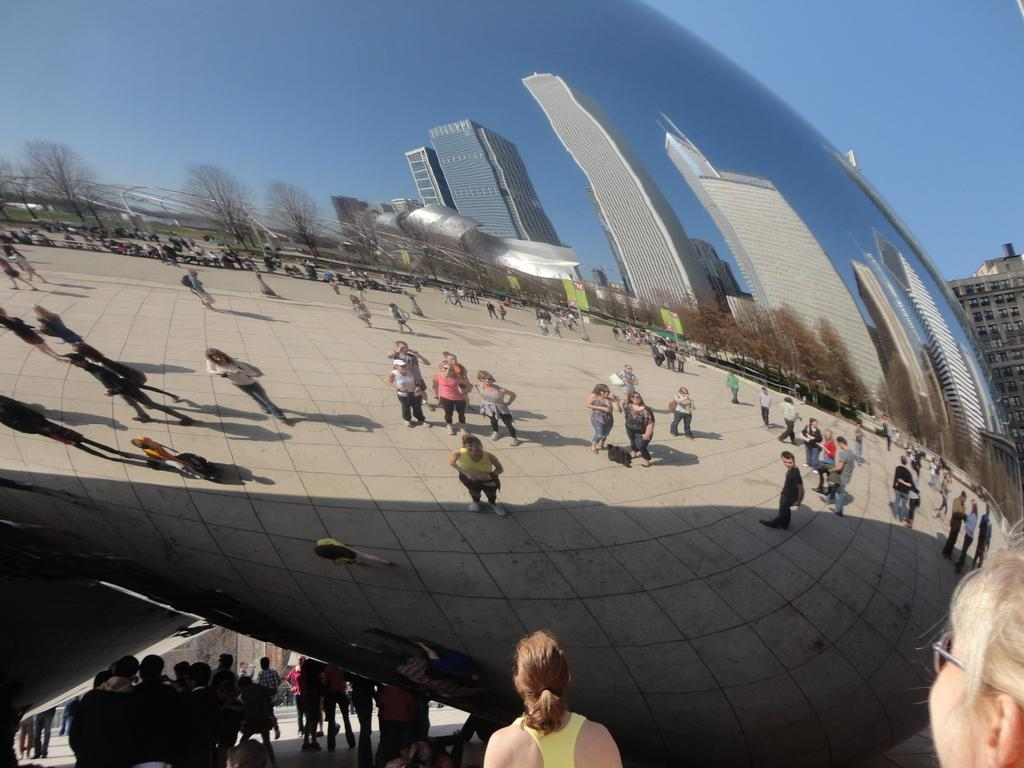What type of structures can be seen in the image? There are buildings in the image. Can you describe the people in the image? There are people standing in the image. What other natural elements are present in the image? There are trees in the image. What man-made objects can be seen in the image? There are poles and boards in the image. Are there any architectural features visible in the image? Yes, there are windows in the image. What can be seen in the background of the image? The sky is visible in the background of the image. How does the sea affect the memory of the people in the image? There is no sea present in the image, so it cannot affect the memory of the people. What type of death is depicted in the image? There is no depiction of death in the image. 